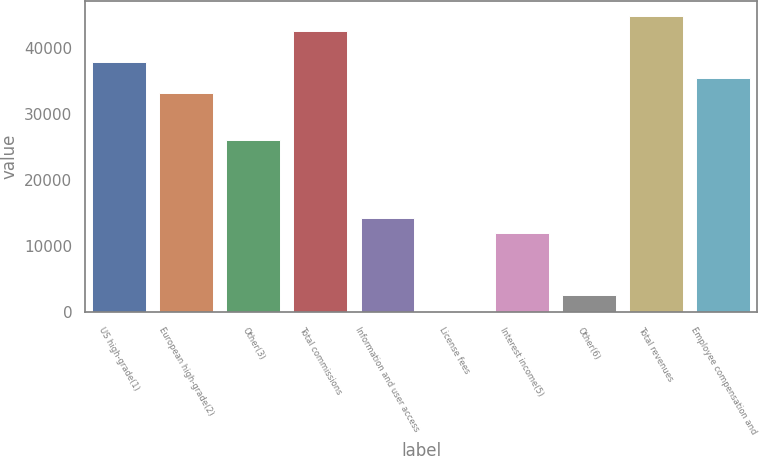<chart> <loc_0><loc_0><loc_500><loc_500><bar_chart><fcel>US high-grade(1)<fcel>European high-grade(2)<fcel>Other(3)<fcel>Total commissions<fcel>Information and user access<fcel>License fees<fcel>Interest income(5)<fcel>Other(6)<fcel>Total revenues<fcel>Employee compensation and<nl><fcel>37880.6<fcel>33175.4<fcel>26117.6<fcel>42585.8<fcel>14354.6<fcel>239<fcel>12002<fcel>2591.6<fcel>44938.4<fcel>35528<nl></chart> 